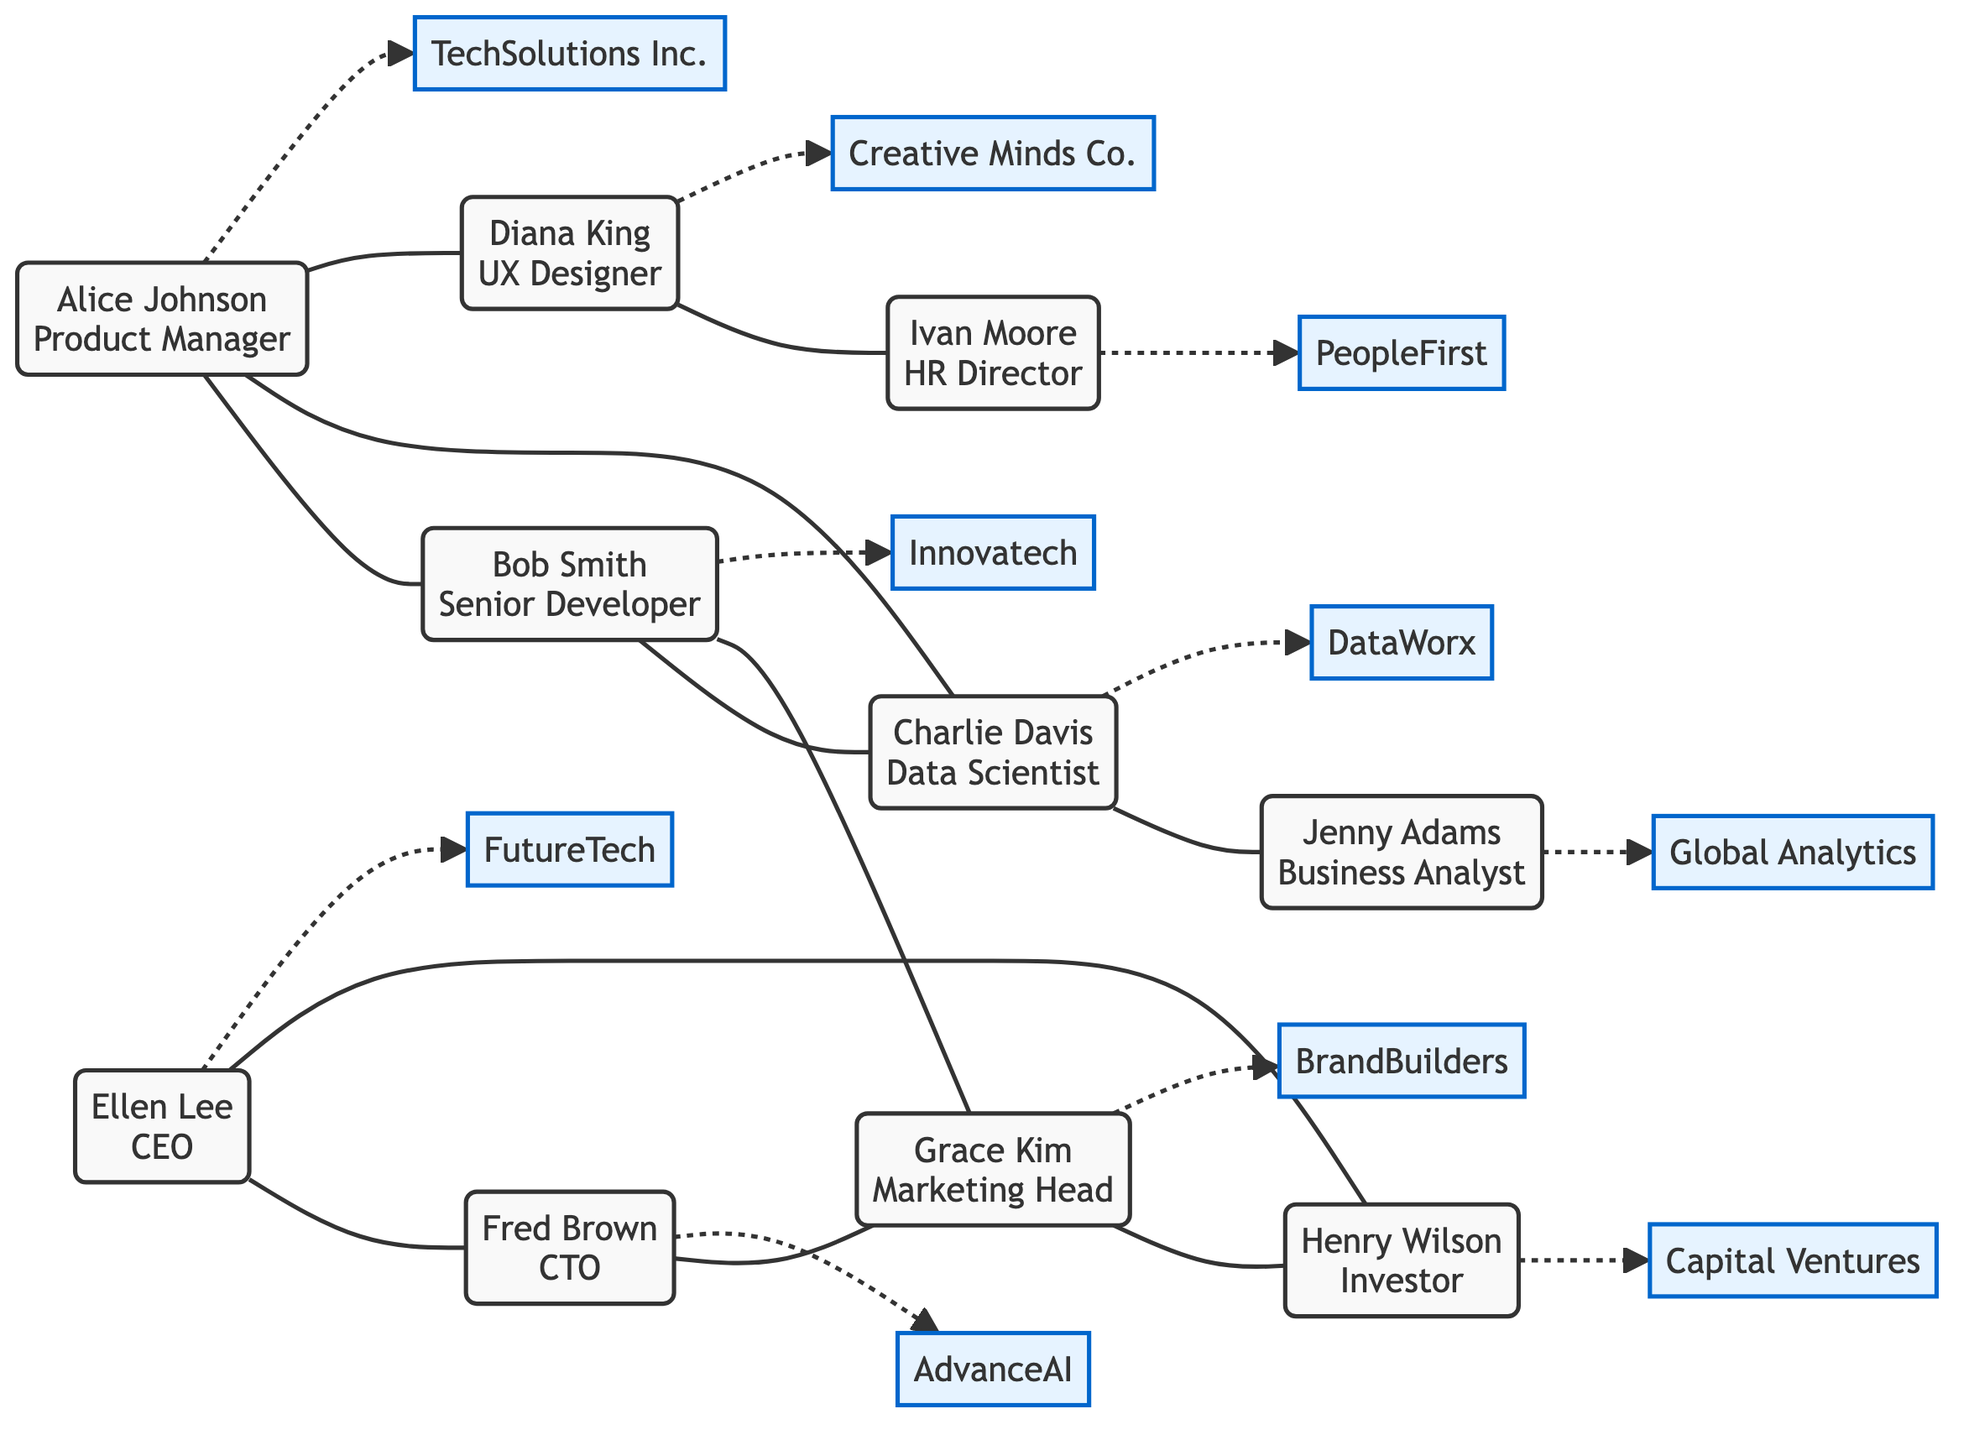What is the total number of nodes in the graph? The graph contains 10 nodes, which represent individuals in the professional network. Each person listed in the "nodes" section is counted, leading to a total count of 10.
Answer: 10 Who is the CEO in the network? The diagram identifies Ellen Lee as the CEO based on the information provided in the nodes. This is indicated by her role next to her name.
Answer: Ellen Lee What type of link exists between Alice Johnson and Charlie Davis? The link between Alice Johnson and Charlie Davis is labeled as a "project partner." This is derived from the specific edge type indicated in the "links" section.
Answer: project partner Which two individuals are connected as strategic partners? Fred Brown and Grace Kim are connected as strategic partners, as described in the links section which specifies this relationship type.
Answer: Fred Brown and Grace Kim How many different types of connections can be observed in the network? Analyzing the links, we can identify several types of connections: colleague, project partner, conference speaker, alumni, collaborator, mentor, workshop organizer, executive peer, board member, and strategic partner. In total, there are 10 unique types of links, illustrating diverse relationships among the individuals.
Answer: 10 Which company does Ivan Moore work for? Ivan Moore is identified as the HR Director at PeopleFirst, which is shown in the nodes section alongside his name.
Answer: PeopleFirst Who is connected to Diana King through a workshop organizer relationship? Ivan Moore is connected to Diana King through the "workshop organizer" relationship. This is evident from the corresponding link in the data provided.
Answer: Ivan Moore Which individual has the highest leadership role shown in the diagram? Ellen Lee holds the highest leadership role as the CEO within the network, which is explicitly mentioned next to her name in the nodes.
Answer: CEO 